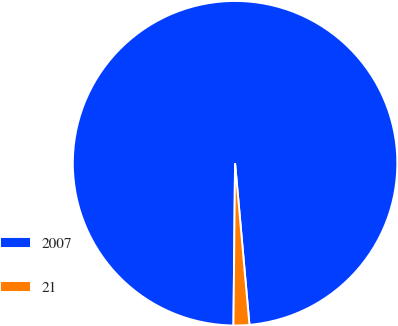<chart> <loc_0><loc_0><loc_500><loc_500><pie_chart><fcel>2007<fcel>21<nl><fcel>98.43%<fcel>1.57%<nl></chart> 